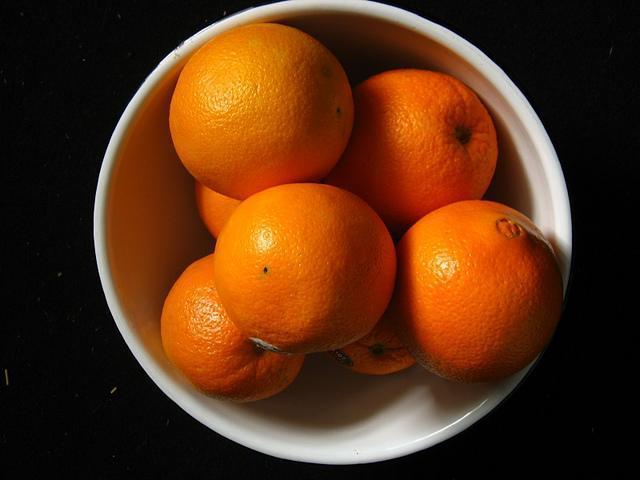How many oranges are these?
Give a very brief answer. 7. How many oranges are in the picture?
Give a very brief answer. 7. How many fruit are in the bowl?
Give a very brief answer. 7. 